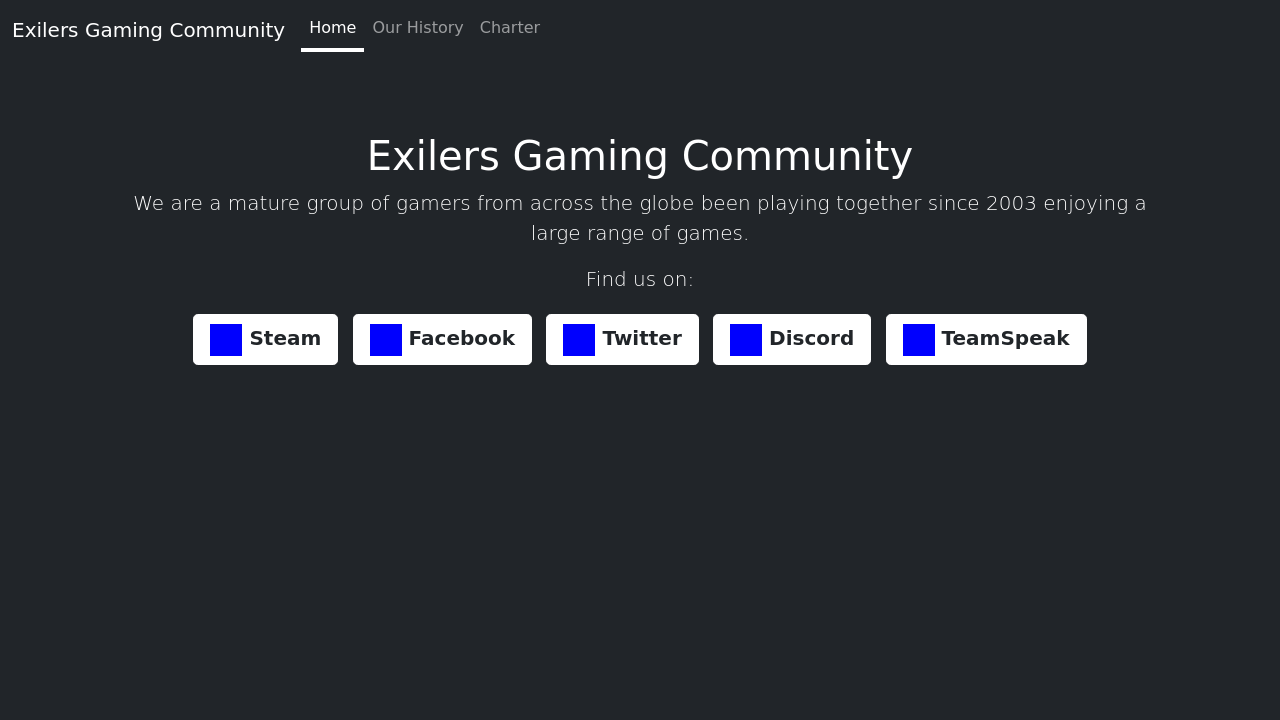What is the purpose of the 'Charter' section on the website? The 'Charter' section on a community website like the Exilers Gaming Community serves as the foundational document that outlines the principles, values, and rules by which the community operates. It sets the tone for member interactions and establishes guidelines for behavior and responsibilities. This document is crucial for maintaining the order and harmony of the community. Would you like a detailed description of what might be included in such a charter? 